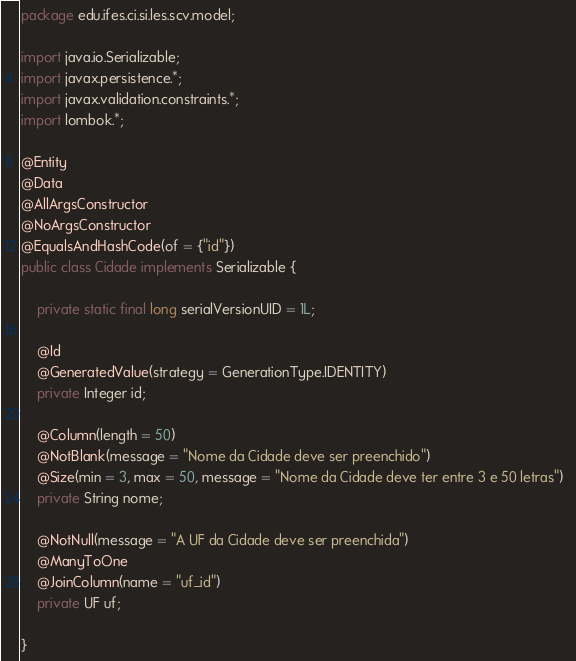<code> <loc_0><loc_0><loc_500><loc_500><_Java_>package edu.ifes.ci.si.les.scv.model;

import java.io.Serializable;
import javax.persistence.*;
import javax.validation.constraints.*;
import lombok.*;

@Entity
@Data
@AllArgsConstructor
@NoArgsConstructor
@EqualsAndHashCode(of = {"id"})
public class Cidade implements Serializable {

    private static final long serialVersionUID = 1L;

    @Id
    @GeneratedValue(strategy = GenerationType.IDENTITY)
    private Integer id;

    @Column(length = 50) 
    @NotBlank(message = "Nome da Cidade deve ser preenchido") 
    @Size(min = 3, max = 50, message = "Nome da Cidade deve ter entre 3 e 50 letras")  
    private String nome;

    @NotNull(message = "A UF da Cidade deve ser preenchida") 
    @ManyToOne
    @JoinColumn(name = "uf_id")
    private UF uf;

}
</code> 